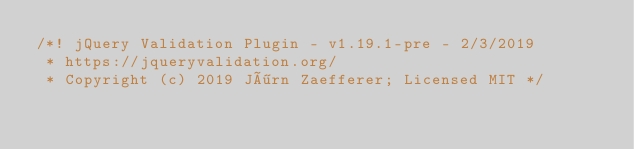Convert code to text. <code><loc_0><loc_0><loc_500><loc_500><_JavaScript_>/*! jQuery Validation Plugin - v1.19.1-pre - 2/3/2019
 * https://jqueryvalidation.org/
 * Copyright (c) 2019 Jörn Zaefferer; Licensed MIT */</code> 